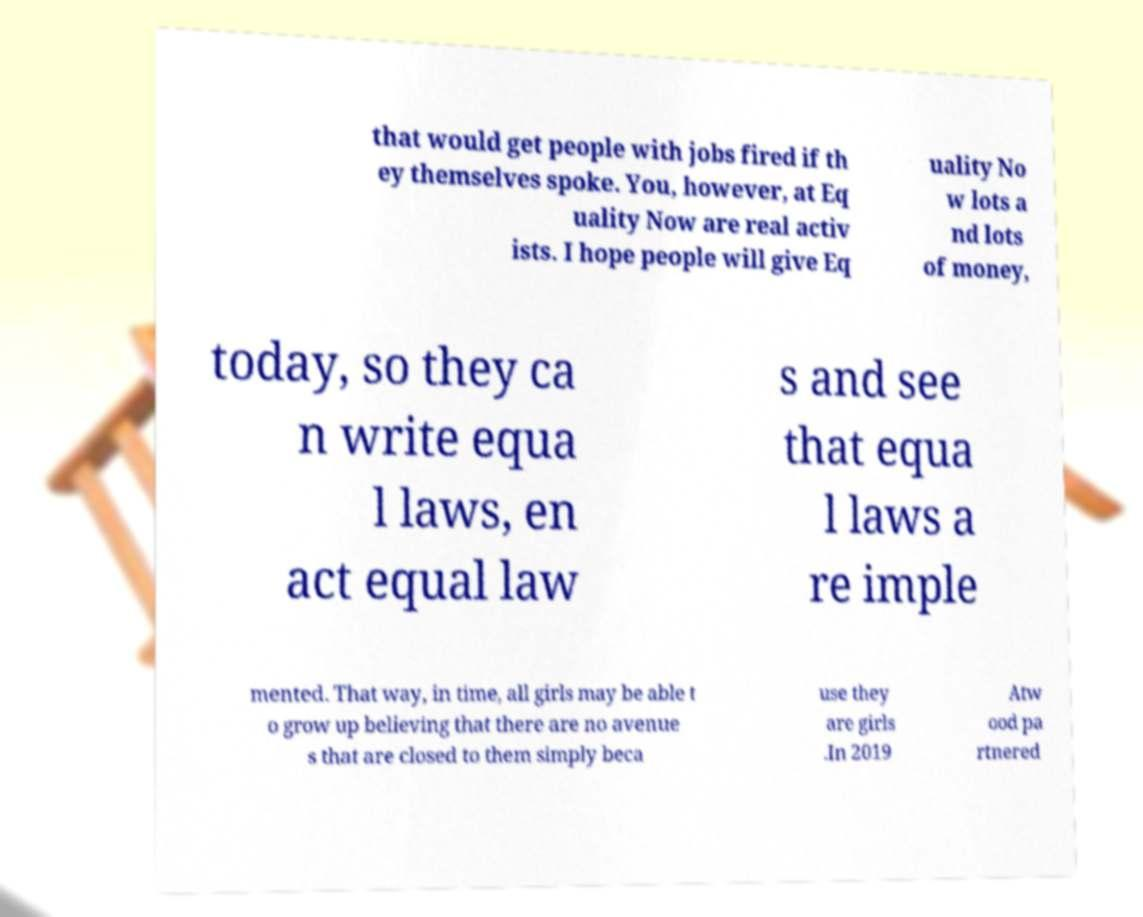Could you extract and type out the text from this image? that would get people with jobs fired if th ey themselves spoke. You, however, at Eq uality Now are real activ ists. I hope people will give Eq uality No w lots a nd lots of money, today, so they ca n write equa l laws, en act equal law s and see that equa l laws a re imple mented. That way, in time, all girls may be able t o grow up believing that there are no avenue s that are closed to them simply beca use they are girls .In 2019 Atw ood pa rtnered 